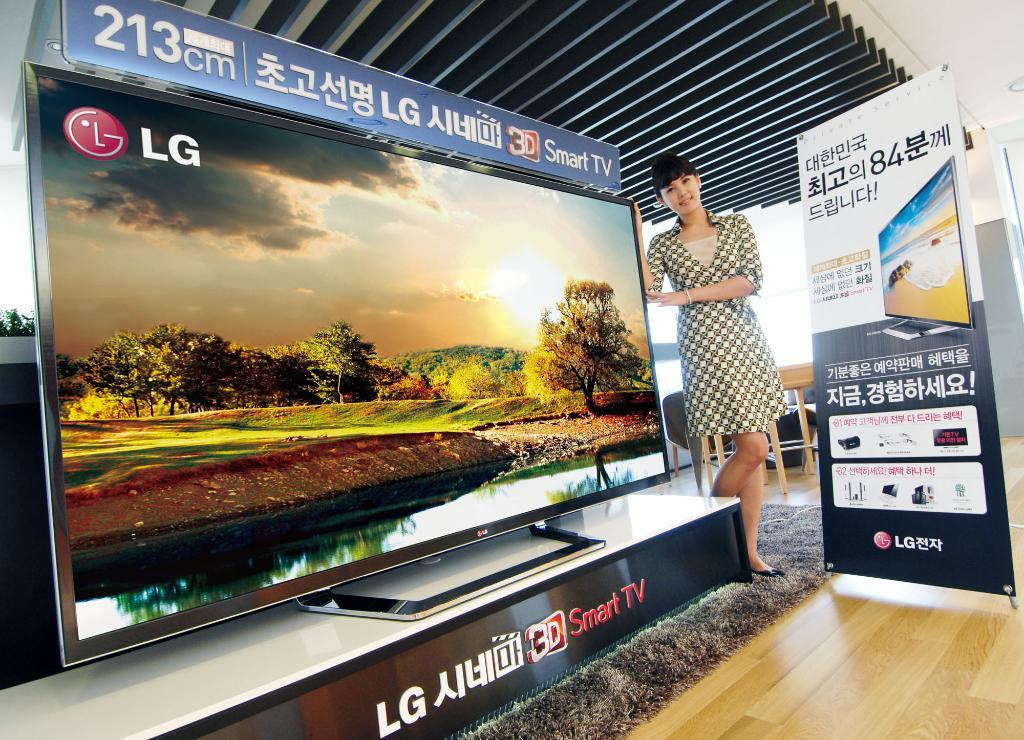<image>
Create a compact narrative representing the image presented. A young woman stands next to a huge LG tv on a display stand 